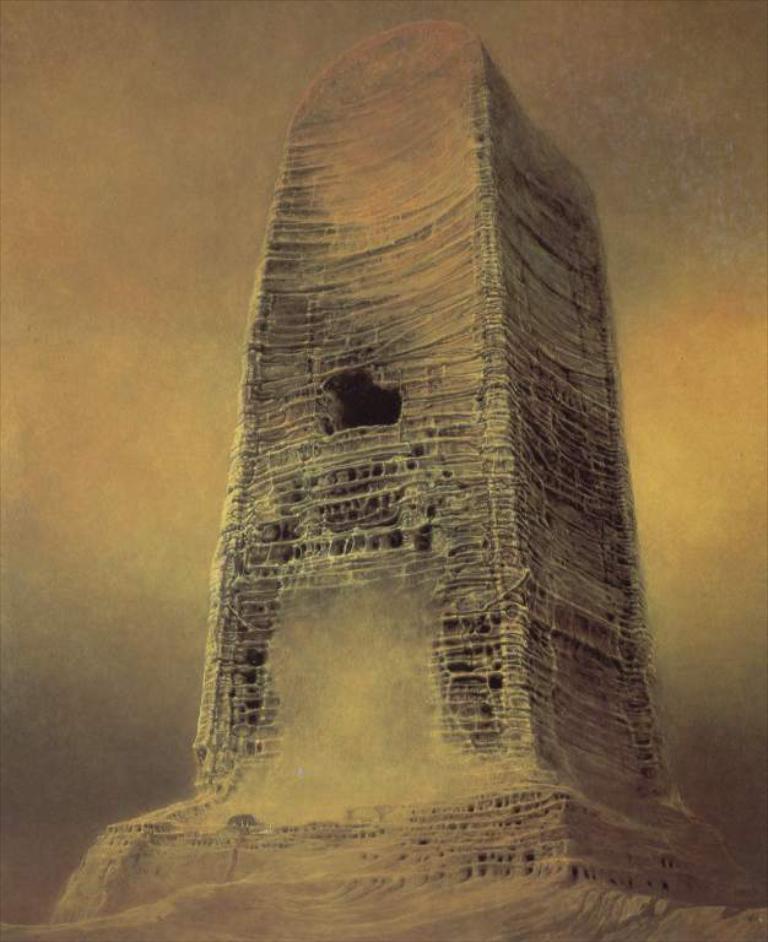Can you describe this image briefly? In this image I can see a painting which is yellow, orange, black and grey in color in which I can see a huge object which is black, orange and cream in color. 